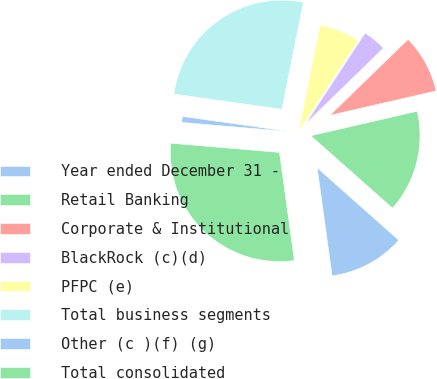Convert chart to OTSL. <chart><loc_0><loc_0><loc_500><loc_500><pie_chart><fcel>Year ended December 31 -<fcel>Retail Banking<fcel>Corporate & Institutional<fcel>BlackRock (c)(d)<fcel>PFPC (e)<fcel>Total business segments<fcel>Other (c )(f) (g)<fcel>Total consolidated<nl><fcel>11.27%<fcel>15.15%<fcel>8.67%<fcel>3.49%<fcel>6.08%<fcel>25.93%<fcel>0.89%<fcel>28.53%<nl></chart> 